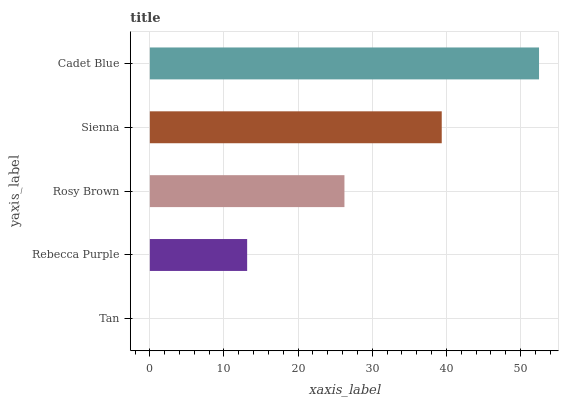Is Tan the minimum?
Answer yes or no. Yes. Is Cadet Blue the maximum?
Answer yes or no. Yes. Is Rebecca Purple the minimum?
Answer yes or no. No. Is Rebecca Purple the maximum?
Answer yes or no. No. Is Rebecca Purple greater than Tan?
Answer yes or no. Yes. Is Tan less than Rebecca Purple?
Answer yes or no. Yes. Is Tan greater than Rebecca Purple?
Answer yes or no. No. Is Rebecca Purple less than Tan?
Answer yes or no. No. Is Rosy Brown the high median?
Answer yes or no. Yes. Is Rosy Brown the low median?
Answer yes or no. Yes. Is Sienna the high median?
Answer yes or no. No. Is Rebecca Purple the low median?
Answer yes or no. No. 